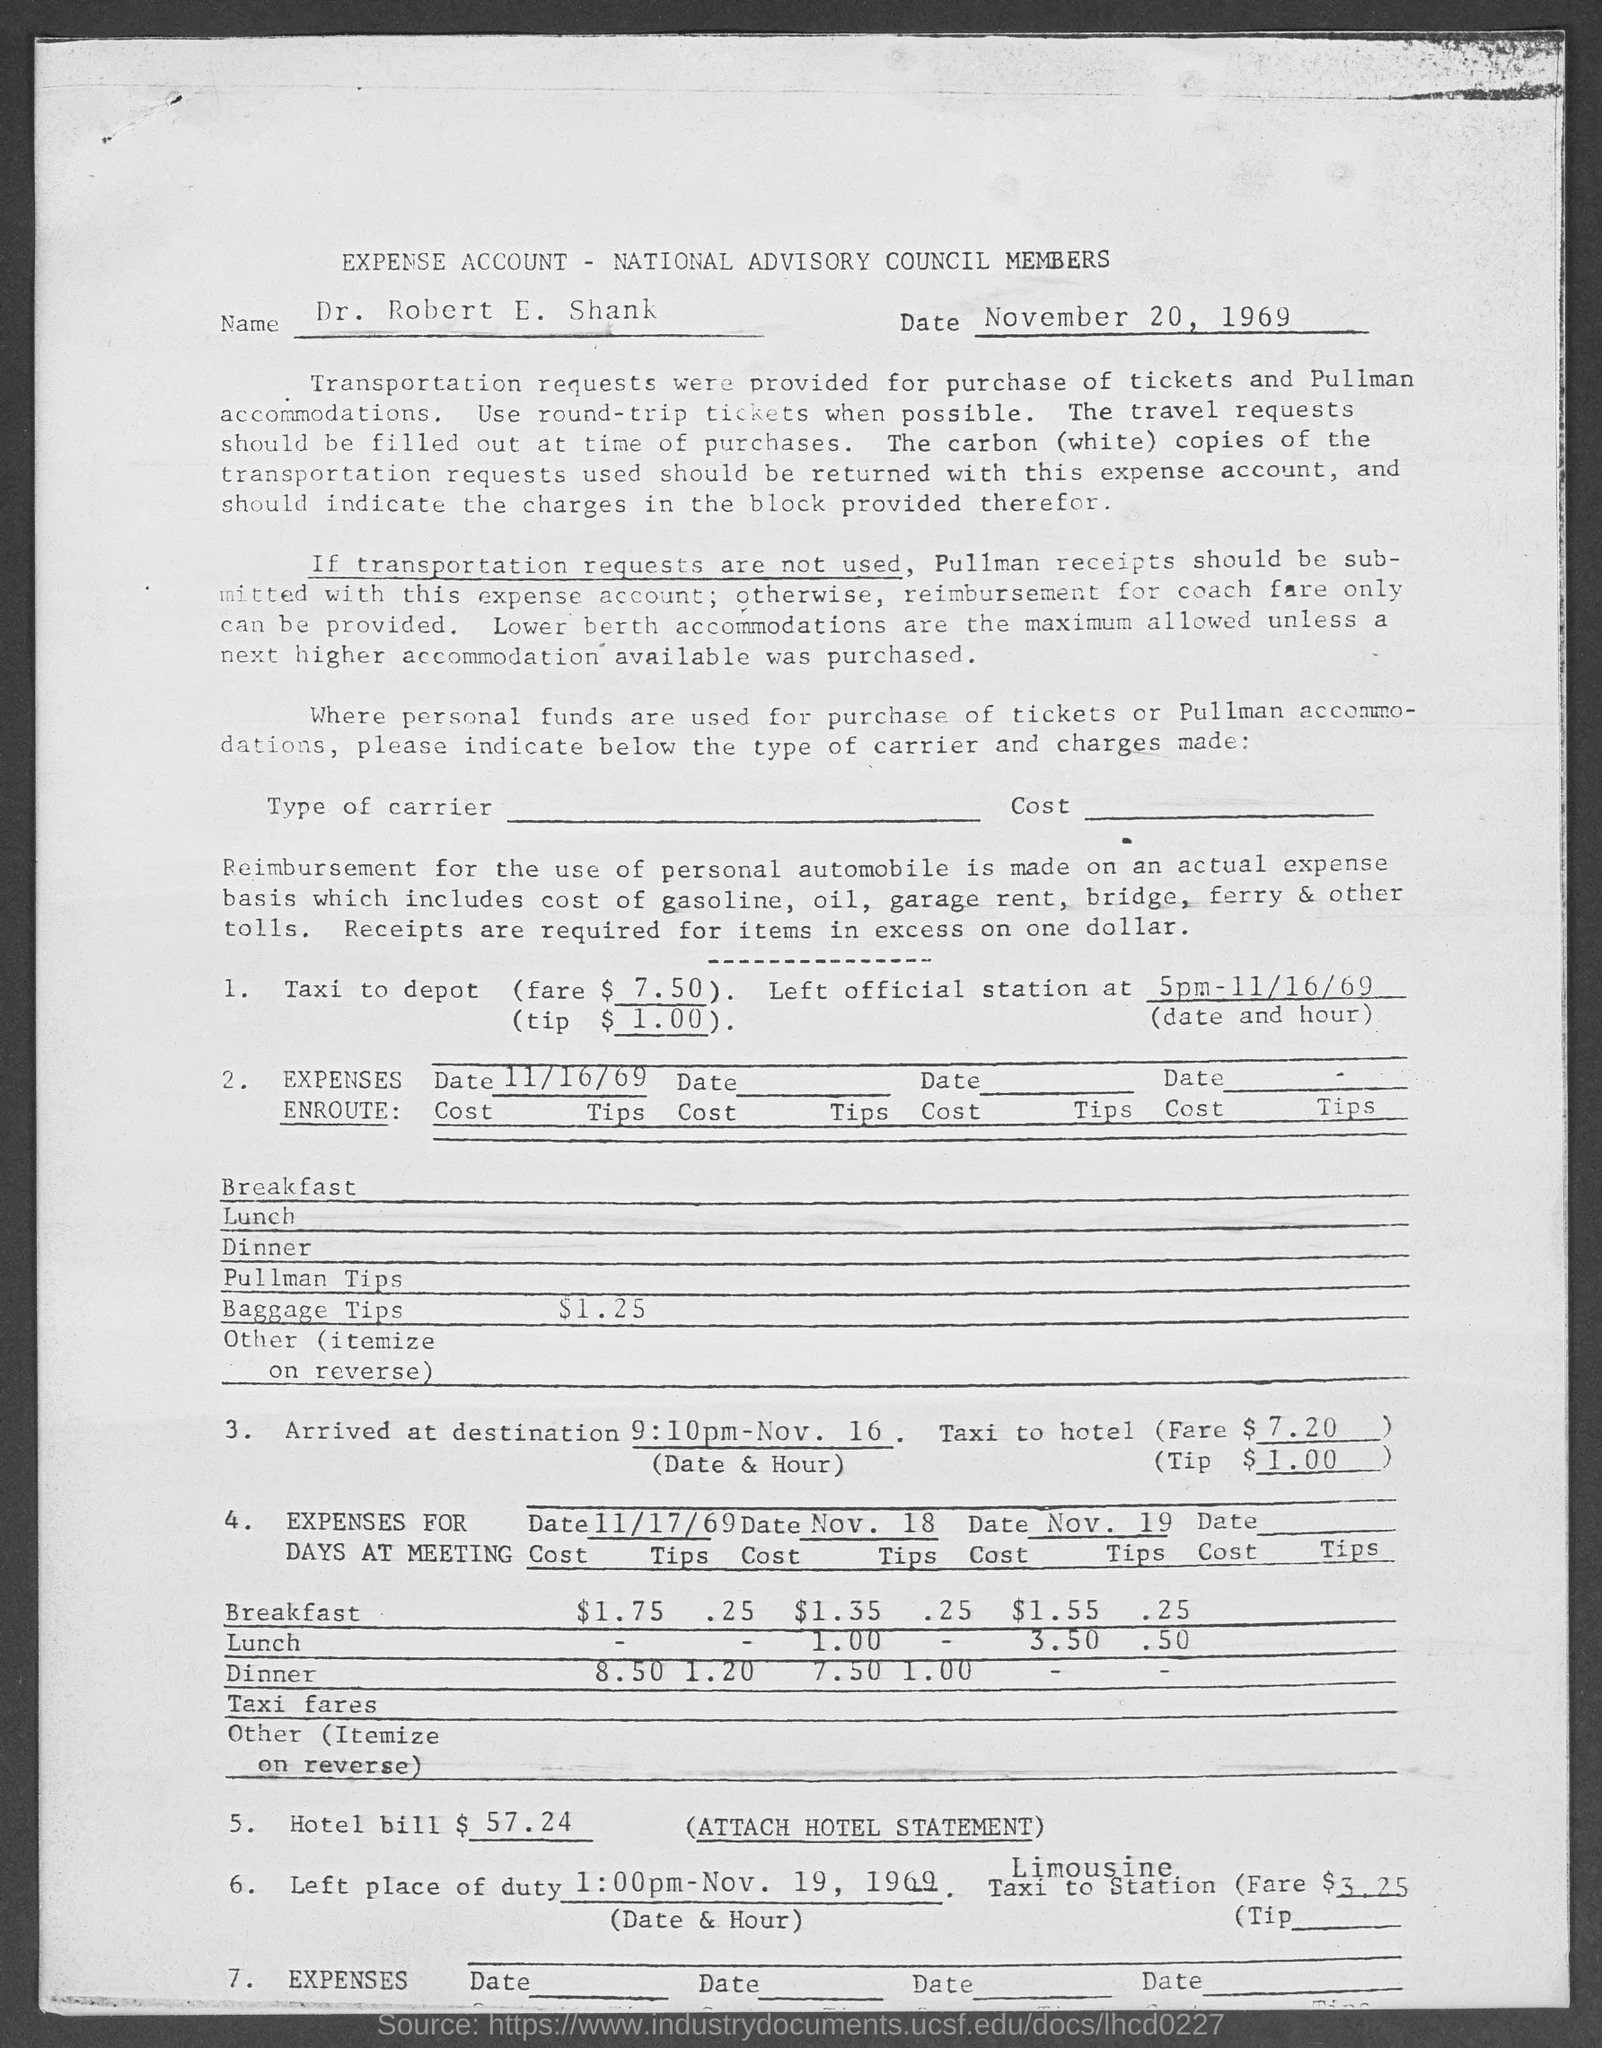What is the name in expense account?
Offer a very short reply. Dr. Robert E. Shank. What is the date in the expense account ?
Offer a very short reply. November 20, 1969. 